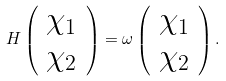Convert formula to latex. <formula><loc_0><loc_0><loc_500><loc_500>H \left ( \begin{array} { c } \chi _ { 1 } \\ \chi _ { 2 } \end{array} \right ) = \omega \left ( \begin{array} { c } \chi _ { 1 } \\ \chi _ { 2 } \end{array} \right ) .</formula> 